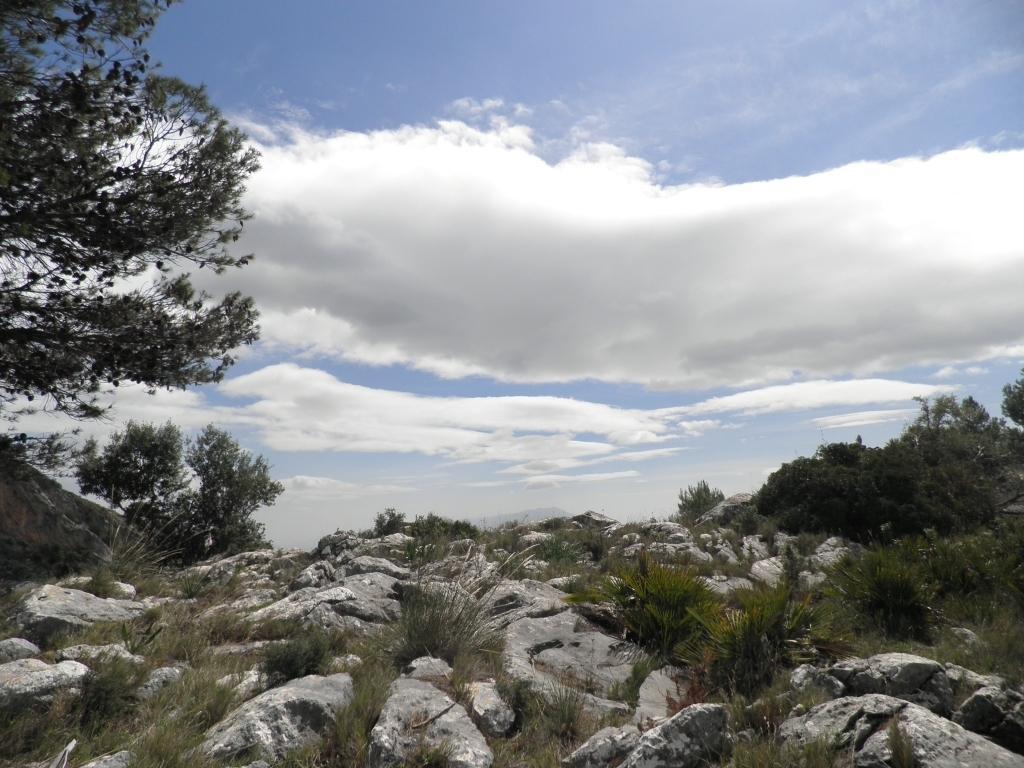How would you summarize this image in a sentence or two? In the picture I can see few rocks and there are few plants beside it and there are trees on either sides of it and the sky is a bit cloudy. 